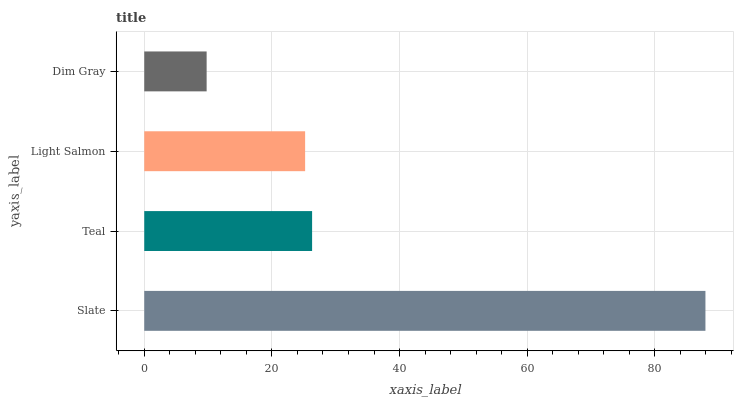Is Dim Gray the minimum?
Answer yes or no. Yes. Is Slate the maximum?
Answer yes or no. Yes. Is Teal the minimum?
Answer yes or no. No. Is Teal the maximum?
Answer yes or no. No. Is Slate greater than Teal?
Answer yes or no. Yes. Is Teal less than Slate?
Answer yes or no. Yes. Is Teal greater than Slate?
Answer yes or no. No. Is Slate less than Teal?
Answer yes or no. No. Is Teal the high median?
Answer yes or no. Yes. Is Light Salmon the low median?
Answer yes or no. Yes. Is Dim Gray the high median?
Answer yes or no. No. Is Teal the low median?
Answer yes or no. No. 